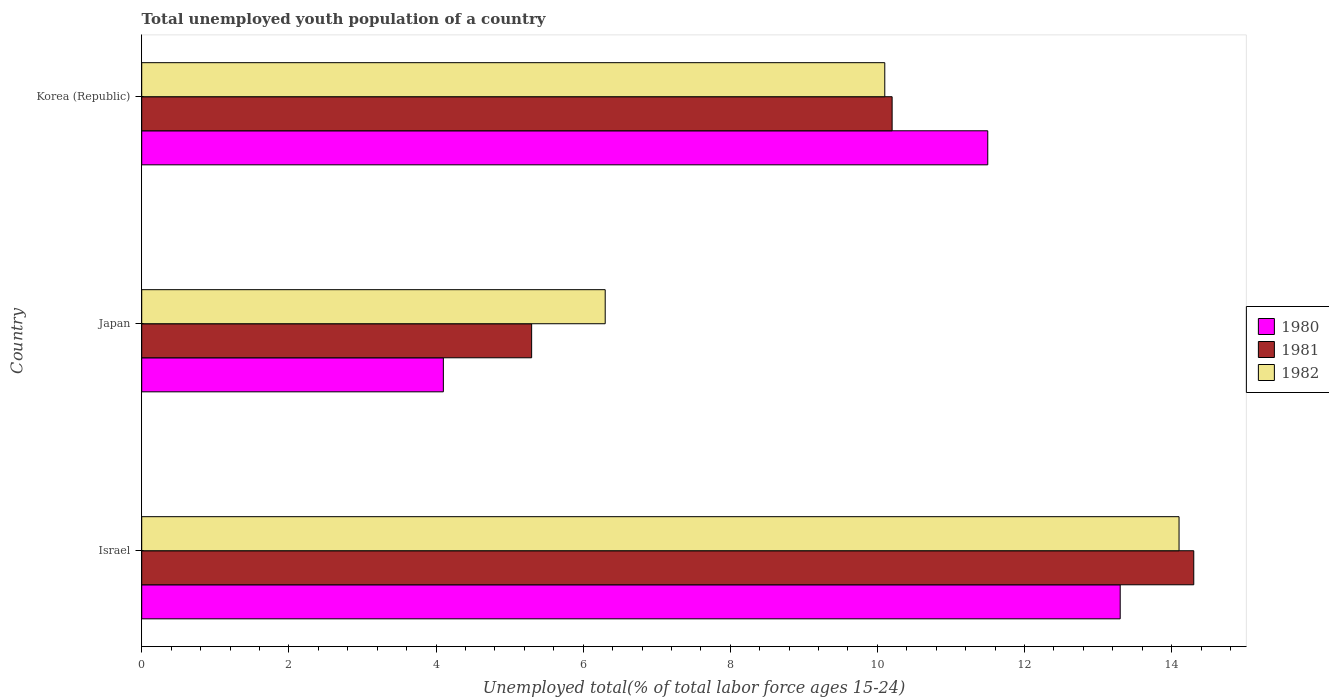How many different coloured bars are there?
Your answer should be compact. 3. How many groups of bars are there?
Keep it short and to the point. 3. Are the number of bars per tick equal to the number of legend labels?
Your response must be concise. Yes. How many bars are there on the 2nd tick from the top?
Provide a short and direct response. 3. How many bars are there on the 3rd tick from the bottom?
Ensure brevity in your answer.  3. What is the label of the 3rd group of bars from the top?
Give a very brief answer. Israel. In how many cases, is the number of bars for a given country not equal to the number of legend labels?
Give a very brief answer. 0. What is the percentage of total unemployed youth population of a country in 1982 in Israel?
Make the answer very short. 14.1. Across all countries, what is the maximum percentage of total unemployed youth population of a country in 1980?
Provide a succinct answer. 13.3. Across all countries, what is the minimum percentage of total unemployed youth population of a country in 1981?
Your answer should be very brief. 5.3. In which country was the percentage of total unemployed youth population of a country in 1981 minimum?
Provide a short and direct response. Japan. What is the total percentage of total unemployed youth population of a country in 1982 in the graph?
Your answer should be compact. 30.5. What is the difference between the percentage of total unemployed youth population of a country in 1980 in Israel and that in Korea (Republic)?
Keep it short and to the point. 1.8. What is the difference between the percentage of total unemployed youth population of a country in 1982 in Israel and the percentage of total unemployed youth population of a country in 1980 in Korea (Republic)?
Ensure brevity in your answer.  2.6. What is the average percentage of total unemployed youth population of a country in 1980 per country?
Make the answer very short. 9.63. What is the difference between the percentage of total unemployed youth population of a country in 1980 and percentage of total unemployed youth population of a country in 1982 in Japan?
Offer a terse response. -2.2. What is the ratio of the percentage of total unemployed youth population of a country in 1980 in Israel to that in Japan?
Provide a succinct answer. 3.24. Is the percentage of total unemployed youth population of a country in 1982 in Israel less than that in Japan?
Offer a terse response. No. Is the difference between the percentage of total unemployed youth population of a country in 1980 in Japan and Korea (Republic) greater than the difference between the percentage of total unemployed youth population of a country in 1982 in Japan and Korea (Republic)?
Your response must be concise. No. What is the difference between the highest and the second highest percentage of total unemployed youth population of a country in 1981?
Provide a succinct answer. 4.1. What is the difference between the highest and the lowest percentage of total unemployed youth population of a country in 1982?
Offer a terse response. 7.8. In how many countries, is the percentage of total unemployed youth population of a country in 1981 greater than the average percentage of total unemployed youth population of a country in 1981 taken over all countries?
Ensure brevity in your answer.  2. Is the sum of the percentage of total unemployed youth population of a country in 1981 in Israel and Japan greater than the maximum percentage of total unemployed youth population of a country in 1982 across all countries?
Ensure brevity in your answer.  Yes. What does the 3rd bar from the bottom in Korea (Republic) represents?
Make the answer very short. 1982. How many countries are there in the graph?
Provide a succinct answer. 3. Are the values on the major ticks of X-axis written in scientific E-notation?
Keep it short and to the point. No. Does the graph contain any zero values?
Your response must be concise. No. Where does the legend appear in the graph?
Your answer should be very brief. Center right. How are the legend labels stacked?
Ensure brevity in your answer.  Vertical. What is the title of the graph?
Make the answer very short. Total unemployed youth population of a country. Does "1961" appear as one of the legend labels in the graph?
Offer a terse response. No. What is the label or title of the X-axis?
Your answer should be very brief. Unemployed total(% of total labor force ages 15-24). What is the label or title of the Y-axis?
Make the answer very short. Country. What is the Unemployed total(% of total labor force ages 15-24) in 1980 in Israel?
Make the answer very short. 13.3. What is the Unemployed total(% of total labor force ages 15-24) of 1981 in Israel?
Your answer should be compact. 14.3. What is the Unemployed total(% of total labor force ages 15-24) of 1982 in Israel?
Your answer should be very brief. 14.1. What is the Unemployed total(% of total labor force ages 15-24) in 1980 in Japan?
Your response must be concise. 4.1. What is the Unemployed total(% of total labor force ages 15-24) of 1981 in Japan?
Your answer should be compact. 5.3. What is the Unemployed total(% of total labor force ages 15-24) of 1982 in Japan?
Provide a succinct answer. 6.3. What is the Unemployed total(% of total labor force ages 15-24) in 1980 in Korea (Republic)?
Make the answer very short. 11.5. What is the Unemployed total(% of total labor force ages 15-24) of 1981 in Korea (Republic)?
Give a very brief answer. 10.2. What is the Unemployed total(% of total labor force ages 15-24) of 1982 in Korea (Republic)?
Provide a short and direct response. 10.1. Across all countries, what is the maximum Unemployed total(% of total labor force ages 15-24) in 1980?
Your answer should be compact. 13.3. Across all countries, what is the maximum Unemployed total(% of total labor force ages 15-24) in 1981?
Your answer should be very brief. 14.3. Across all countries, what is the maximum Unemployed total(% of total labor force ages 15-24) in 1982?
Your answer should be compact. 14.1. Across all countries, what is the minimum Unemployed total(% of total labor force ages 15-24) of 1980?
Provide a succinct answer. 4.1. Across all countries, what is the minimum Unemployed total(% of total labor force ages 15-24) in 1981?
Offer a very short reply. 5.3. Across all countries, what is the minimum Unemployed total(% of total labor force ages 15-24) of 1982?
Keep it short and to the point. 6.3. What is the total Unemployed total(% of total labor force ages 15-24) in 1980 in the graph?
Provide a succinct answer. 28.9. What is the total Unemployed total(% of total labor force ages 15-24) in 1981 in the graph?
Ensure brevity in your answer.  29.8. What is the total Unemployed total(% of total labor force ages 15-24) in 1982 in the graph?
Make the answer very short. 30.5. What is the difference between the Unemployed total(% of total labor force ages 15-24) of 1982 in Israel and that in Japan?
Ensure brevity in your answer.  7.8. What is the difference between the Unemployed total(% of total labor force ages 15-24) in 1980 in Israel and that in Korea (Republic)?
Give a very brief answer. 1.8. What is the difference between the Unemployed total(% of total labor force ages 15-24) of 1980 in Japan and that in Korea (Republic)?
Your answer should be very brief. -7.4. What is the difference between the Unemployed total(% of total labor force ages 15-24) of 1980 in Israel and the Unemployed total(% of total labor force ages 15-24) of 1981 in Japan?
Offer a terse response. 8. What is the difference between the Unemployed total(% of total labor force ages 15-24) of 1980 in Israel and the Unemployed total(% of total labor force ages 15-24) of 1982 in Japan?
Your answer should be compact. 7. What is the difference between the Unemployed total(% of total labor force ages 15-24) in 1980 in Israel and the Unemployed total(% of total labor force ages 15-24) in 1982 in Korea (Republic)?
Your response must be concise. 3.2. What is the difference between the Unemployed total(% of total labor force ages 15-24) in 1980 in Japan and the Unemployed total(% of total labor force ages 15-24) in 1981 in Korea (Republic)?
Ensure brevity in your answer.  -6.1. What is the average Unemployed total(% of total labor force ages 15-24) of 1980 per country?
Provide a short and direct response. 9.63. What is the average Unemployed total(% of total labor force ages 15-24) of 1981 per country?
Your answer should be compact. 9.93. What is the average Unemployed total(% of total labor force ages 15-24) of 1982 per country?
Offer a very short reply. 10.17. What is the difference between the Unemployed total(% of total labor force ages 15-24) in 1980 and Unemployed total(% of total labor force ages 15-24) in 1981 in Israel?
Keep it short and to the point. -1. What is the difference between the Unemployed total(% of total labor force ages 15-24) of 1980 and Unemployed total(% of total labor force ages 15-24) of 1982 in Israel?
Ensure brevity in your answer.  -0.8. What is the difference between the Unemployed total(% of total labor force ages 15-24) in 1980 and Unemployed total(% of total labor force ages 15-24) in 1982 in Japan?
Ensure brevity in your answer.  -2.2. What is the difference between the Unemployed total(% of total labor force ages 15-24) in 1981 and Unemployed total(% of total labor force ages 15-24) in 1982 in Japan?
Offer a very short reply. -1. What is the difference between the Unemployed total(% of total labor force ages 15-24) of 1980 and Unemployed total(% of total labor force ages 15-24) of 1981 in Korea (Republic)?
Your answer should be compact. 1.3. What is the difference between the Unemployed total(% of total labor force ages 15-24) in 1980 and Unemployed total(% of total labor force ages 15-24) in 1982 in Korea (Republic)?
Offer a very short reply. 1.4. What is the difference between the Unemployed total(% of total labor force ages 15-24) in 1981 and Unemployed total(% of total labor force ages 15-24) in 1982 in Korea (Republic)?
Provide a succinct answer. 0.1. What is the ratio of the Unemployed total(% of total labor force ages 15-24) of 1980 in Israel to that in Japan?
Your answer should be very brief. 3.24. What is the ratio of the Unemployed total(% of total labor force ages 15-24) in 1981 in Israel to that in Japan?
Your answer should be compact. 2.7. What is the ratio of the Unemployed total(% of total labor force ages 15-24) of 1982 in Israel to that in Japan?
Provide a short and direct response. 2.24. What is the ratio of the Unemployed total(% of total labor force ages 15-24) of 1980 in Israel to that in Korea (Republic)?
Your answer should be compact. 1.16. What is the ratio of the Unemployed total(% of total labor force ages 15-24) in 1981 in Israel to that in Korea (Republic)?
Make the answer very short. 1.4. What is the ratio of the Unemployed total(% of total labor force ages 15-24) in 1982 in Israel to that in Korea (Republic)?
Offer a terse response. 1.4. What is the ratio of the Unemployed total(% of total labor force ages 15-24) of 1980 in Japan to that in Korea (Republic)?
Offer a very short reply. 0.36. What is the ratio of the Unemployed total(% of total labor force ages 15-24) in 1981 in Japan to that in Korea (Republic)?
Keep it short and to the point. 0.52. What is the ratio of the Unemployed total(% of total labor force ages 15-24) of 1982 in Japan to that in Korea (Republic)?
Give a very brief answer. 0.62. What is the difference between the highest and the second highest Unemployed total(% of total labor force ages 15-24) of 1981?
Your answer should be compact. 4.1. What is the difference between the highest and the lowest Unemployed total(% of total labor force ages 15-24) of 1980?
Offer a very short reply. 9.2. What is the difference between the highest and the lowest Unemployed total(% of total labor force ages 15-24) of 1982?
Provide a short and direct response. 7.8. 